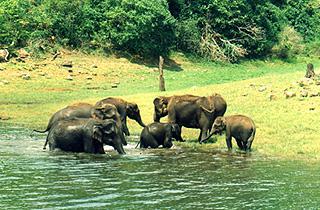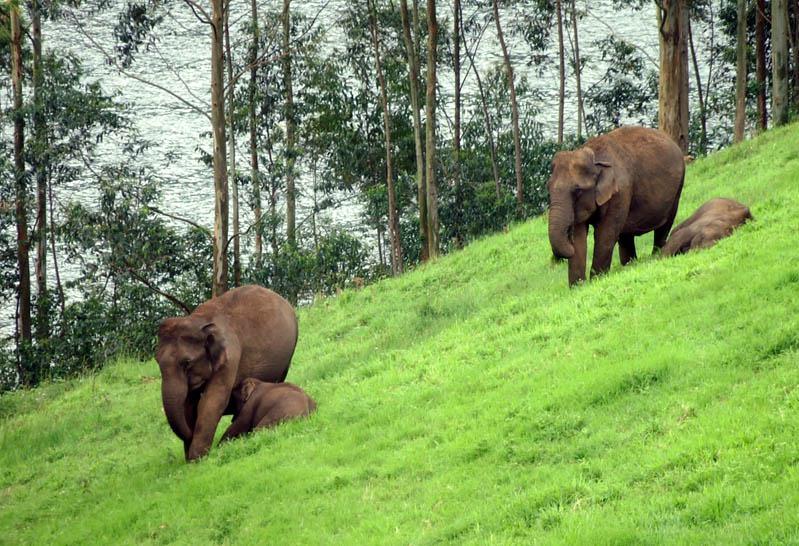The first image is the image on the left, the second image is the image on the right. Examine the images to the left and right. Is the description "The animals in the image on the left are standing in the water." accurate? Answer yes or no. Yes. 